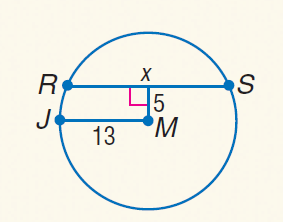Answer the mathemtical geometry problem and directly provide the correct option letter.
Question: Find x.
Choices: A: 5 B: 12 C: 24 D: 26 C 